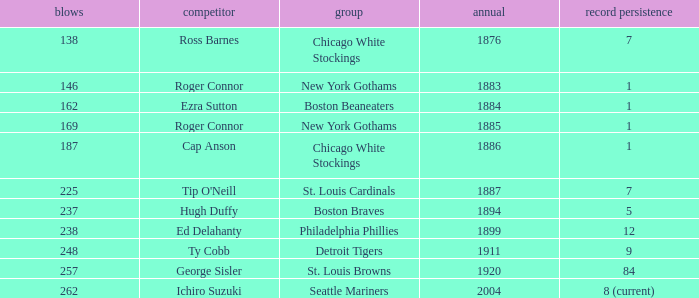Name the least hits for year less than 1920 and player of ed delahanty 238.0. 